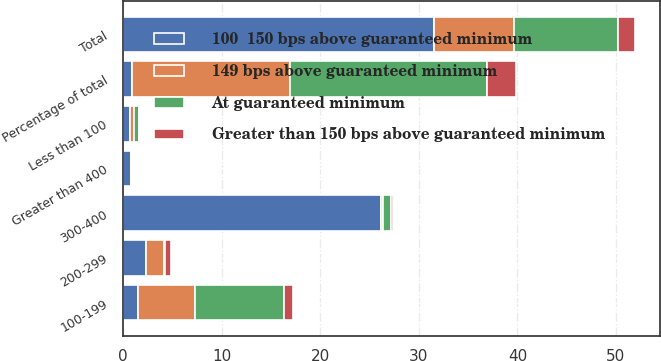Convert chart. <chart><loc_0><loc_0><loc_500><loc_500><stacked_bar_chart><ecel><fcel>Less than 100<fcel>100-199<fcel>200-299<fcel>300-400<fcel>Greater than 400<fcel>Total<fcel>Percentage of total<nl><fcel>100  150 bps above guaranteed minimum<fcel>0.7<fcel>1.5<fcel>2.3<fcel>26.2<fcel>0.8<fcel>31.5<fcel>0.9<nl><fcel>At guaranteed minimum<fcel>0.5<fcel>9<fcel>0.2<fcel>0.8<fcel>0<fcel>10.5<fcel>20<nl><fcel>149 bps above guaranteed minimum<fcel>0.4<fcel>5.8<fcel>1.8<fcel>0.2<fcel>0<fcel>8.2<fcel>16<nl><fcel>Greater than 150 bps above guaranteed minimum<fcel>0<fcel>0.9<fcel>0.6<fcel>0.2<fcel>0<fcel>1.7<fcel>3<nl></chart> 